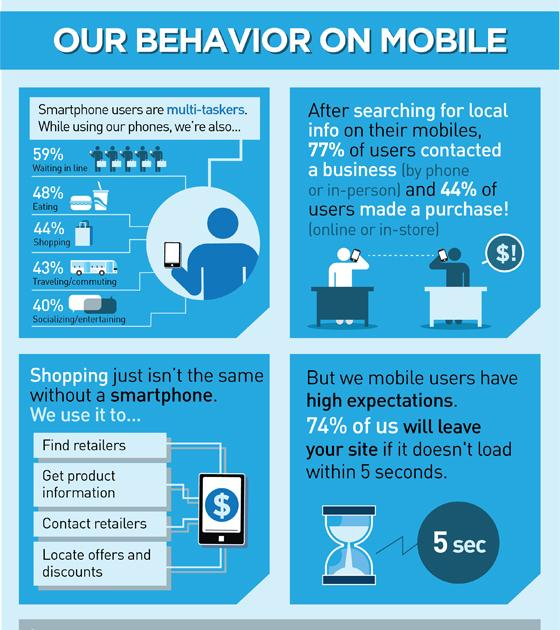Indicate a few pertinent items in this graphic. The minimum website loading time beyond which users tend to leave the site is approximately 5 seconds. Today, the use of smartphones has become a common practice in finding retailers, locating offers and discounts. According to a recent survey, 48% of people use smartphones while eating. According to our survey, 43% of users reported using their smartphone while traveling. 